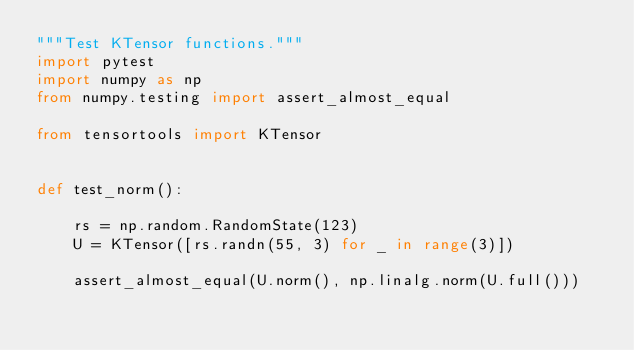Convert code to text. <code><loc_0><loc_0><loc_500><loc_500><_Python_>"""Test KTensor functions."""
import pytest
import numpy as np
from numpy.testing import assert_almost_equal

from tensortools import KTensor


def test_norm():

    rs = np.random.RandomState(123)
    U = KTensor([rs.randn(55, 3) for _ in range(3)])

    assert_almost_equal(U.norm(), np.linalg.norm(U.full()))
</code> 